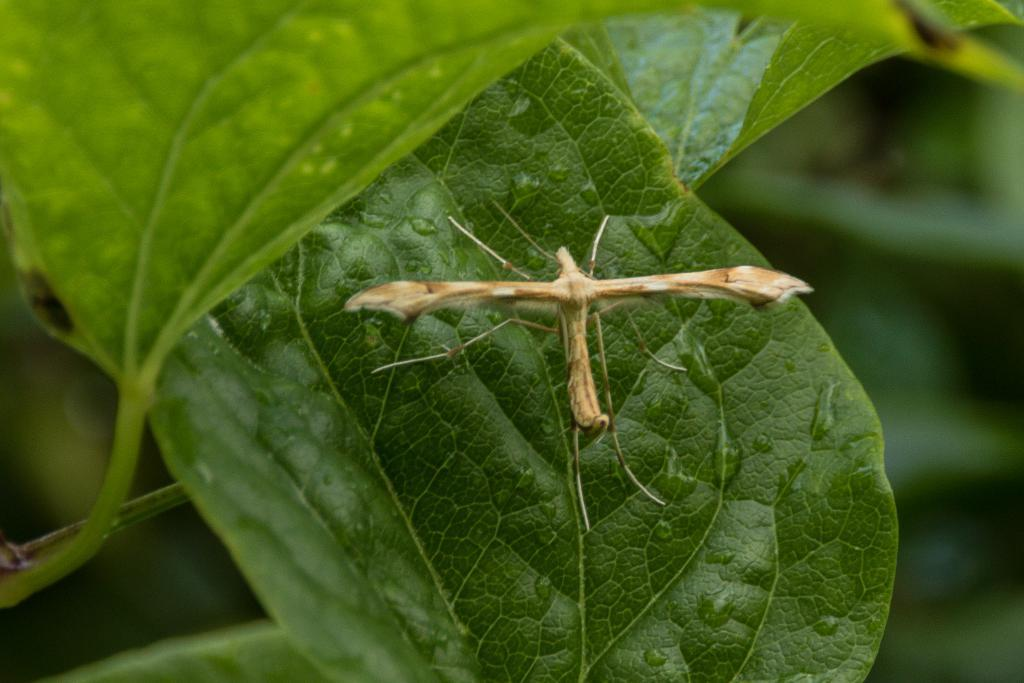What is the main subject of the image? There is an insect on a green leaf in the image. What else can be seen on the leaf? There are leaves visible in the image. What type of vegetation is present in the background? There are green plants in the background of the image. How would you describe the background of the image? The background of the image is blurred. What type of soap can be seen on the insect's back in the image? There is no soap present in the image; it features an insect on a leaf with no soap visible. How many clams are visible on the leaf in the image? There are no clams present in the image; it features an insect on a leaf with no clams visible. 